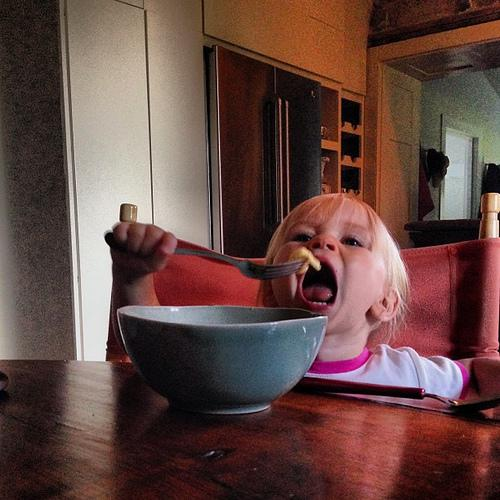Question: when is the kid doing?
Choices:
A. Jumping.
B. Drawing.
C. Eating.
D. Running.
Answer with the letter. Answer: C Question: what hand is the kid using?
Choices:
A. His dad's hand.
B. The right hand.
C. The left hand.
D. His mom's hand.
Answer with the letter. Answer: B Question: what is the table made of?
Choices:
A. Metal.
B. Wood.
C. Glass.
D. Plastic.
Answer with the letter. Answer: B Question: where is the kid?
Choices:
A. In the pool.
B. On the surfboard.
C. At school.
D. At the table.
Answer with the letter. Answer: D 